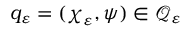Convert formula to latex. <formula><loc_0><loc_0><loc_500><loc_500>q _ { \varepsilon } = ( \chi _ { \varepsilon } , \psi ) \in \mathcal { Q } _ { \varepsilon }</formula> 